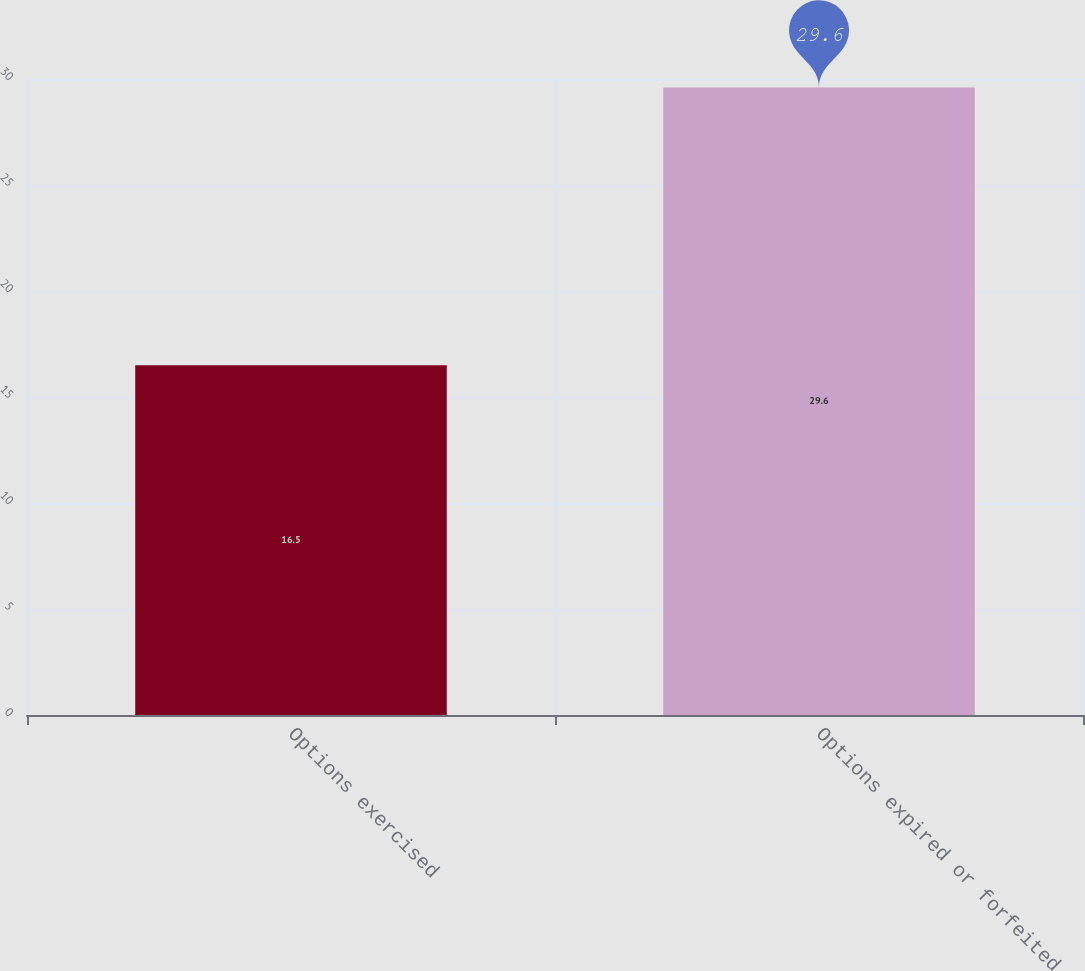<chart> <loc_0><loc_0><loc_500><loc_500><bar_chart><fcel>Options exercised<fcel>Options expired or forfeited<nl><fcel>16.5<fcel>29.6<nl></chart> 